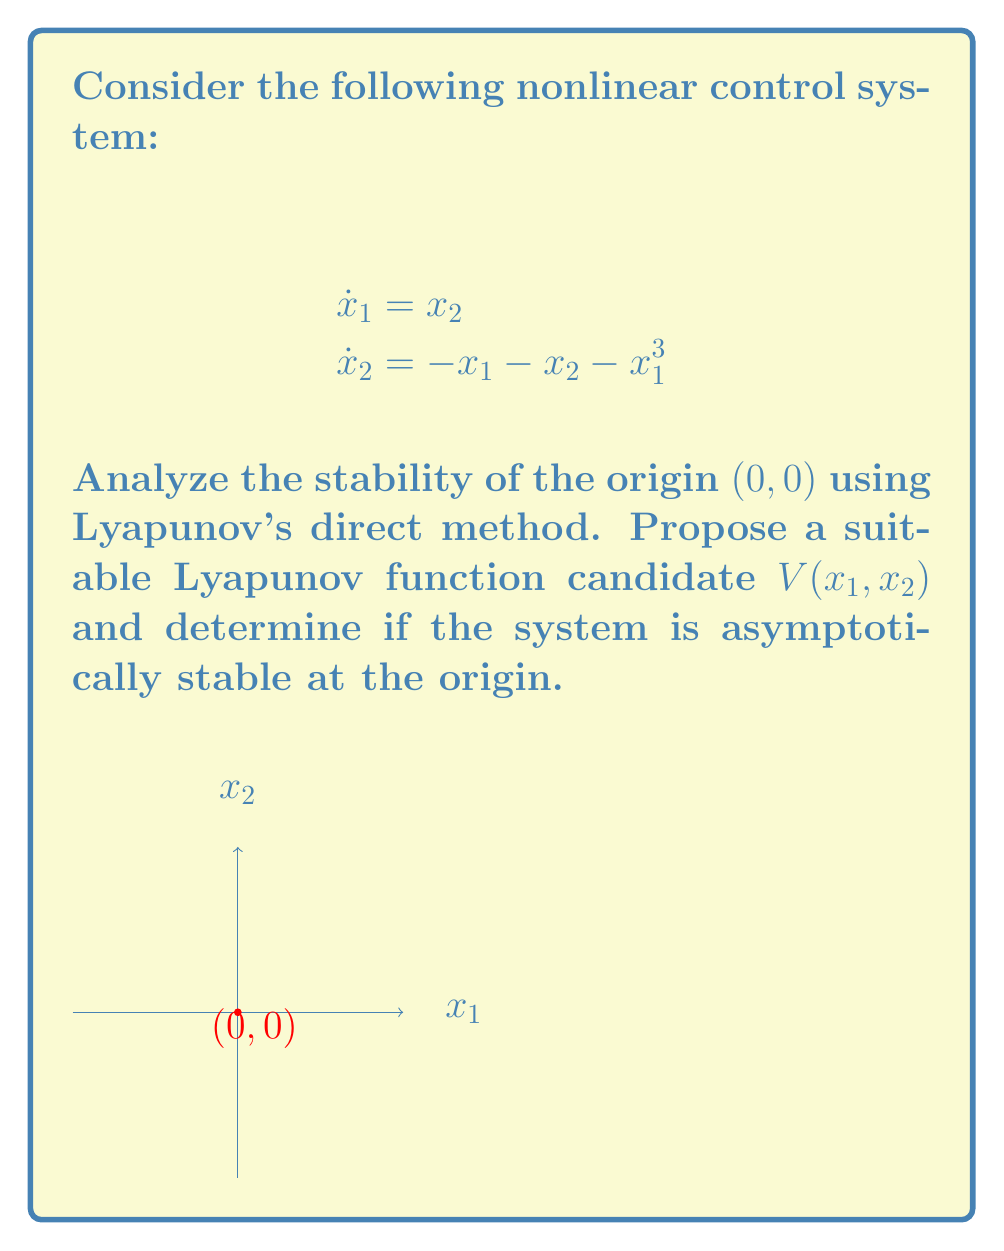Could you help me with this problem? To analyze the stability of the nonlinear system using Lyapunov's direct method, we'll follow these steps:

1) Propose a Lyapunov function candidate:
Let's choose $V(x_1, x_2) = \frac{1}{2}x_1^2 + \frac{1}{2}x_2^2 + \frac{1}{4}x_1^4$

2) Verify that $V(x_1, x_2)$ is positive definite:
$V(0,0) = 0$ and $V(x_1, x_2) > 0$ for all $(x_1, x_2) \neq (0,0)$

3) Calculate $\dot{V}(x_1, x_2)$:
$$\dot{V} = \frac{\partial V}{\partial x_1}\dot{x}_1 + \frac{\partial V}{\partial x_2}\dot{x}_2$$
$$\dot{V} = (x_1 + x_1^3)x_2 + x_2(-x_1 - x_2 - x_1^3)$$
$$\dot{V} = -x_2^2$$

4) Analyze $\dot{V}(x_1, x_2)$:
$\dot{V}$ is negative semi-definite (i.e., $\dot{V} \leq 0$ for all $x_1, x_2$)

5) Apply LaSalle's Invariance Principle:
The set where $\dot{V} = 0$ is $\{(x_1, x_2) | x_2 = 0\}$
In this set, the system dynamics reduce to:
$$\dot{x}_1 = 0$$
$$\dot{x}_2 = -x_1 - x_1^3$$
The only invariant subset of this set is the origin $(0,0)$

6) Conclusion:
By Lyapunov's direct method and LaSalle's Invariance Principle, the origin is asymptotically stable.
Answer: The system is asymptotically stable at the origin $(0,0)$. 